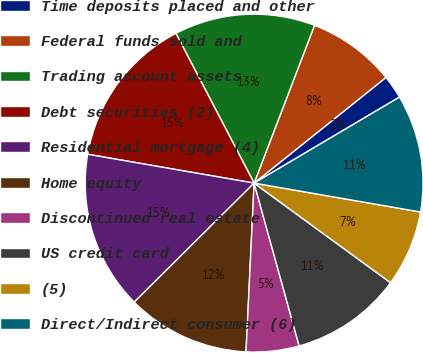Convert chart to OTSL. <chart><loc_0><loc_0><loc_500><loc_500><pie_chart><fcel>Time deposits placed and other<fcel>Federal funds sold and<fcel>Trading account assets<fcel>Debt securities (2)<fcel>Residential mortgage (4)<fcel>Home equity<fcel>Discontinued real estate<fcel>US credit card<fcel>(5)<fcel>Direct/Indirect consumer (6)<nl><fcel>2.25%<fcel>8.43%<fcel>13.48%<fcel>14.61%<fcel>15.17%<fcel>11.8%<fcel>5.06%<fcel>10.67%<fcel>7.3%<fcel>11.24%<nl></chart> 